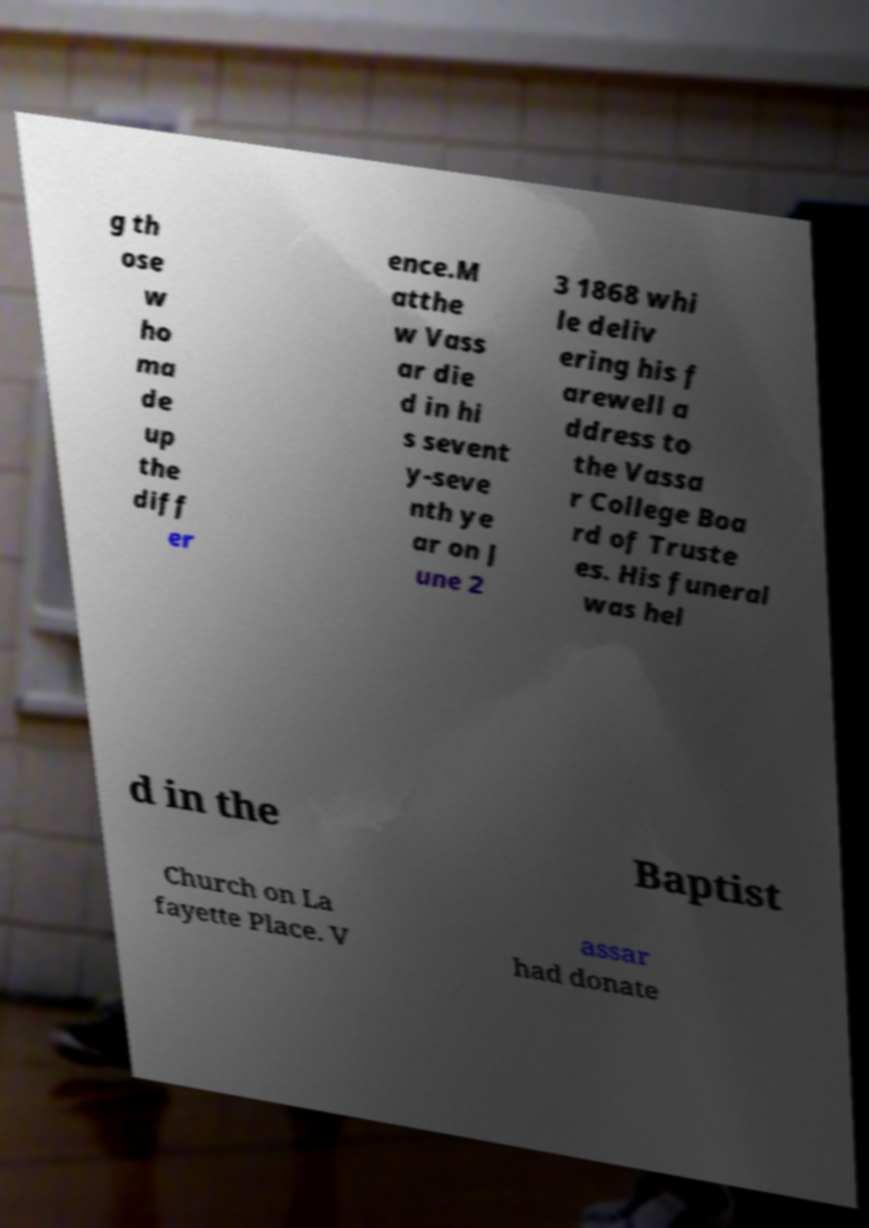Could you extract and type out the text from this image? g th ose w ho ma de up the diff er ence.M atthe w Vass ar die d in hi s sevent y-seve nth ye ar on J une 2 3 1868 whi le deliv ering his f arewell a ddress to the Vassa r College Boa rd of Truste es. His funeral was hel d in the Baptist Church on La fayette Place. V assar had donate 